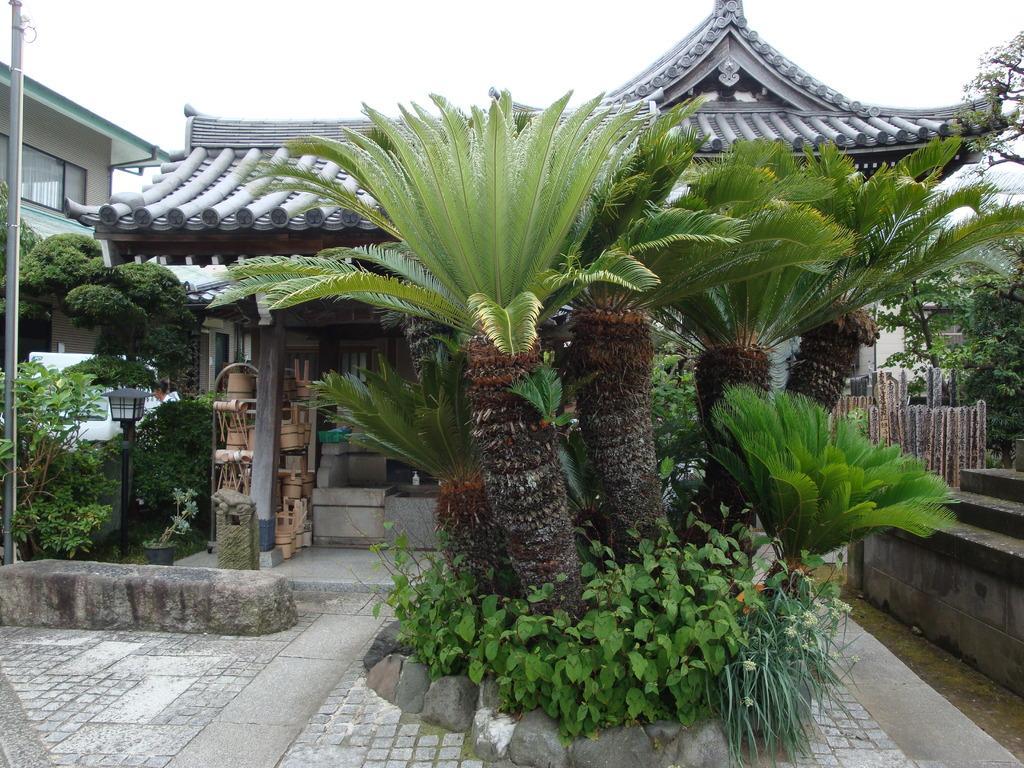How would you summarize this image in a sentence or two? In this image there are some plants and trees in middle of this image and there are some buildings in the background. There is a sky at top of this image. 